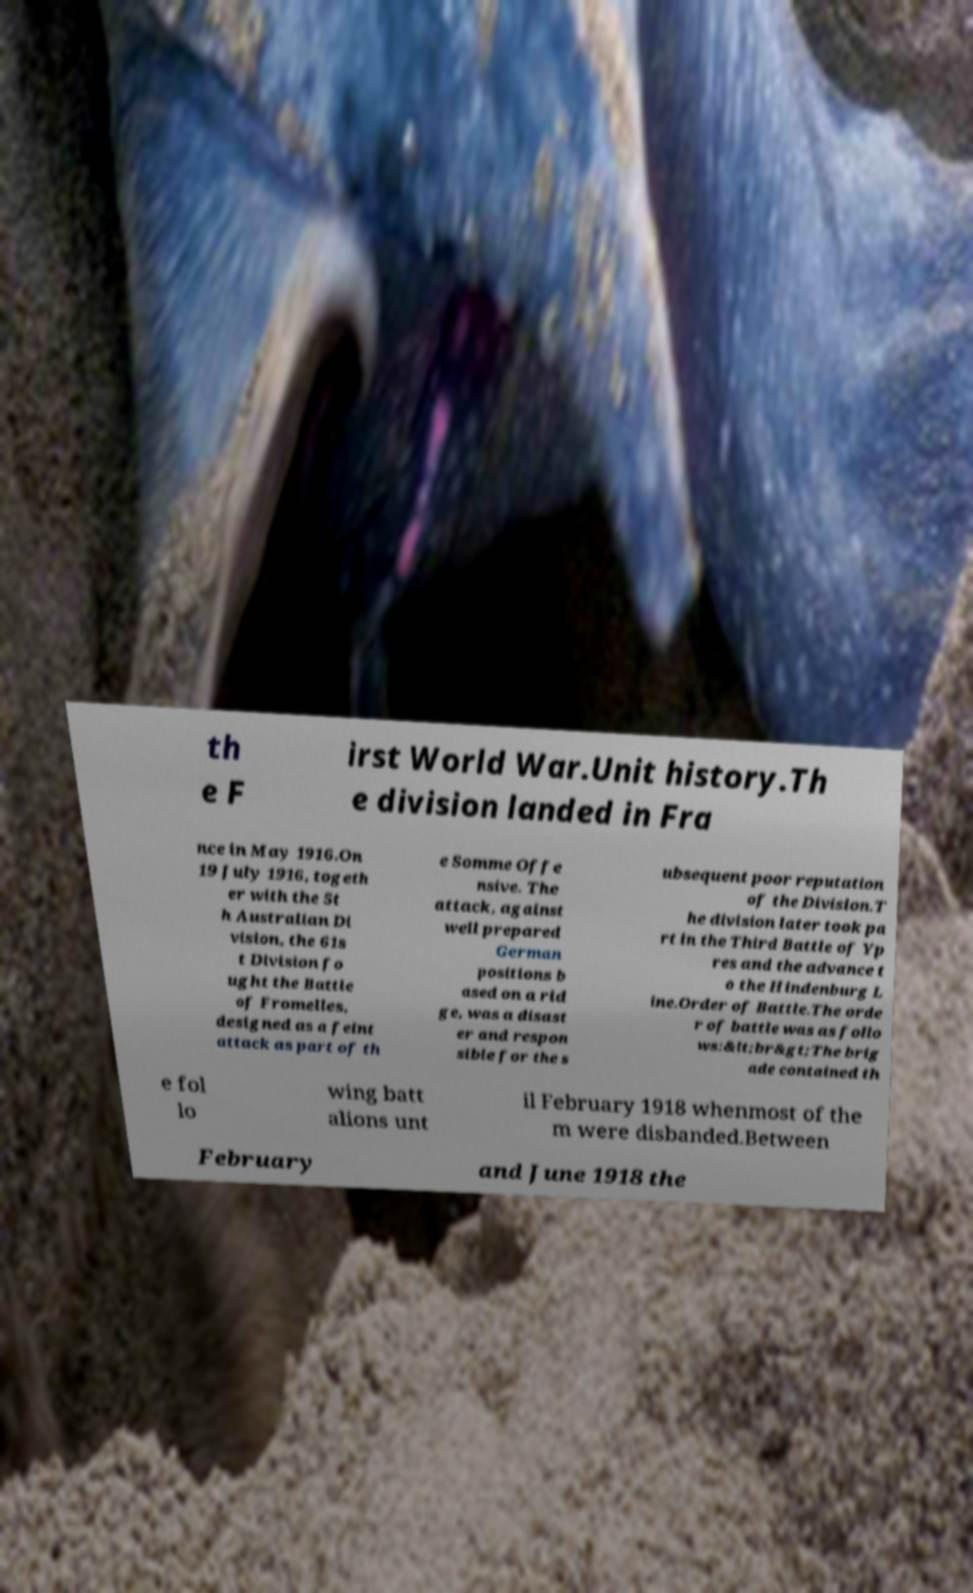I need the written content from this picture converted into text. Can you do that? th e F irst World War.Unit history.Th e division landed in Fra nce in May 1916.On 19 July 1916, togeth er with the 5t h Australian Di vision, the 61s t Division fo ught the Battle of Fromelles, designed as a feint attack as part of th e Somme Offe nsive. The attack, against well prepared German positions b ased on a rid ge, was a disast er and respon sible for the s ubsequent poor reputation of the Division.T he division later took pa rt in the Third Battle of Yp res and the advance t o the Hindenburg L ine.Order of Battle.The orde r of battle was as follo ws:&lt;br&gt;The brig ade contained th e fol lo wing batt alions unt il February 1918 whenmost of the m were disbanded.Between February and June 1918 the 